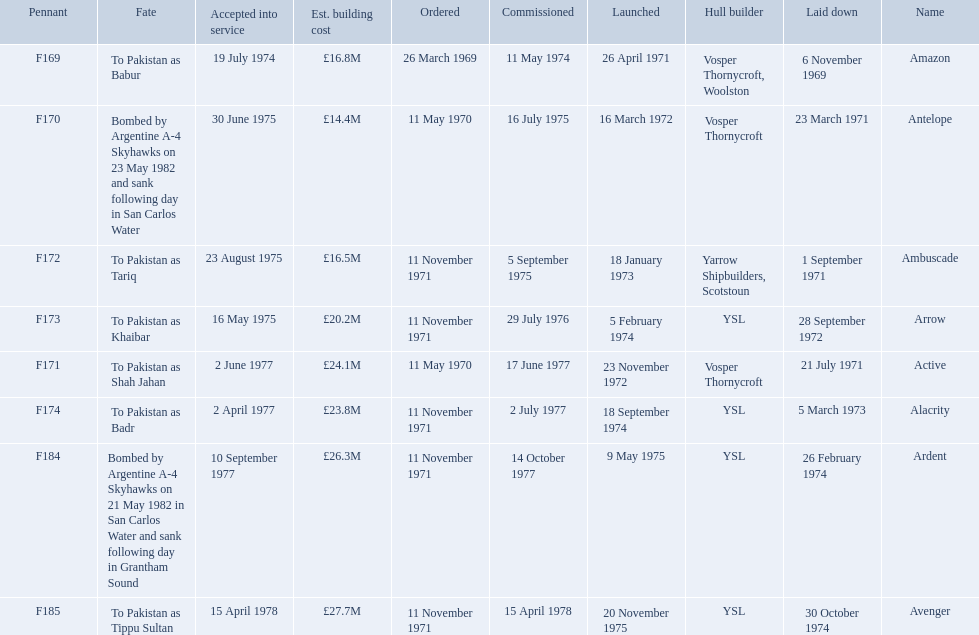Which type 21 frigate ships were to be built by ysl in the 1970s? Arrow, Alacrity, Ardent, Avenger. Of these ships, which one had the highest estimated building cost? Avenger. 